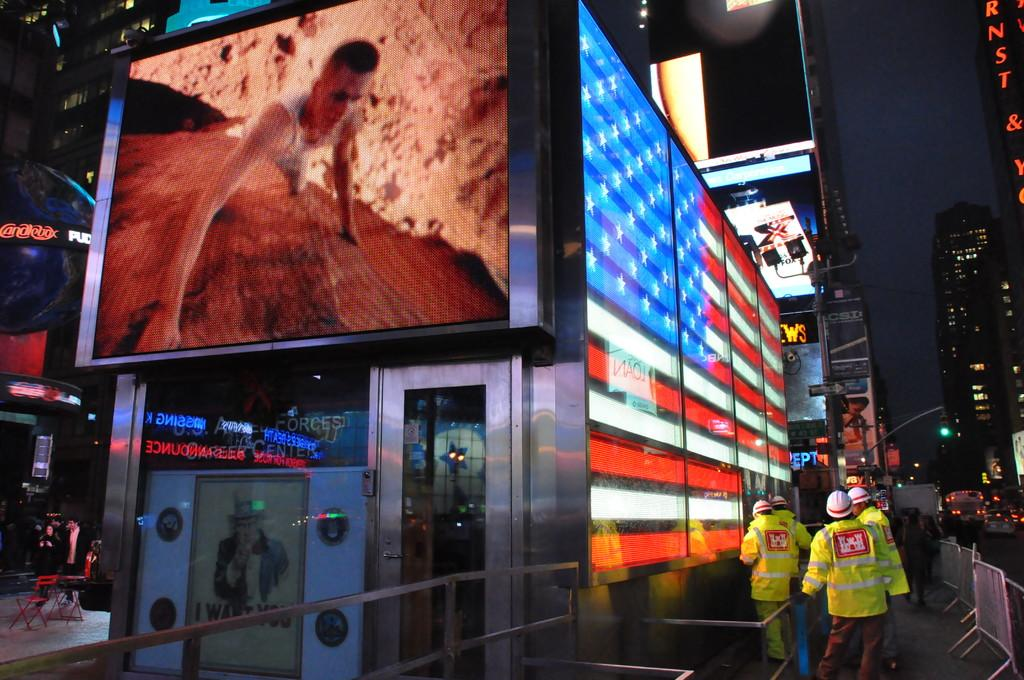What type of structures can be seen in the image? There are buildings in the image. What feature is present on the walls of the buildings? Display screens are present on the walls of the buildings. What are the people in the image doing? There are persons standing and walking on the roads. What type of security feature is visible in the image? Iron grills are visible in the image. What objects are present to control traffic in the image? Barrier poles are present in the image. What signage is visible in the image? Name boards are present in the image. What part of the natural environment is visible in the image? The sky is visible in the image. What type of weather can be seen in the image? The provided facts do not mention any specific weather conditions, so it cannot be determined from the image. What edge is visible in the image? There is no mention of an edge in the provided facts, so it cannot be determined from the image. 